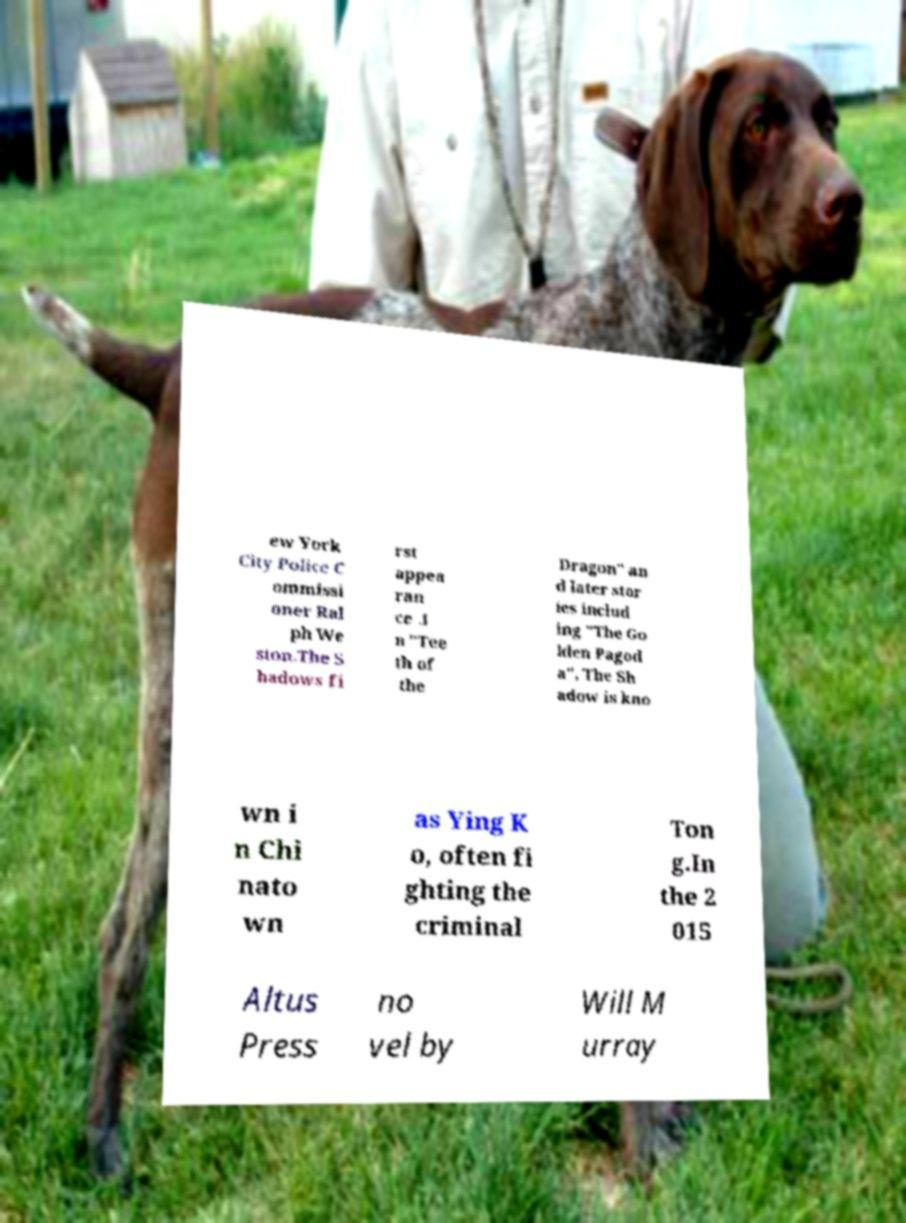Please read and relay the text visible in this image. What does it say? ew York City Police C ommissi oner Ral ph We ston.The S hadows fi rst appea ran ce .I n "Tee th of the Dragon" an d later stor ies includ ing "The Go lden Pagod a", The Sh adow is kno wn i n Chi nato wn as Ying K o, often fi ghting the criminal Ton g.In the 2 015 Altus Press no vel by Will M urray 